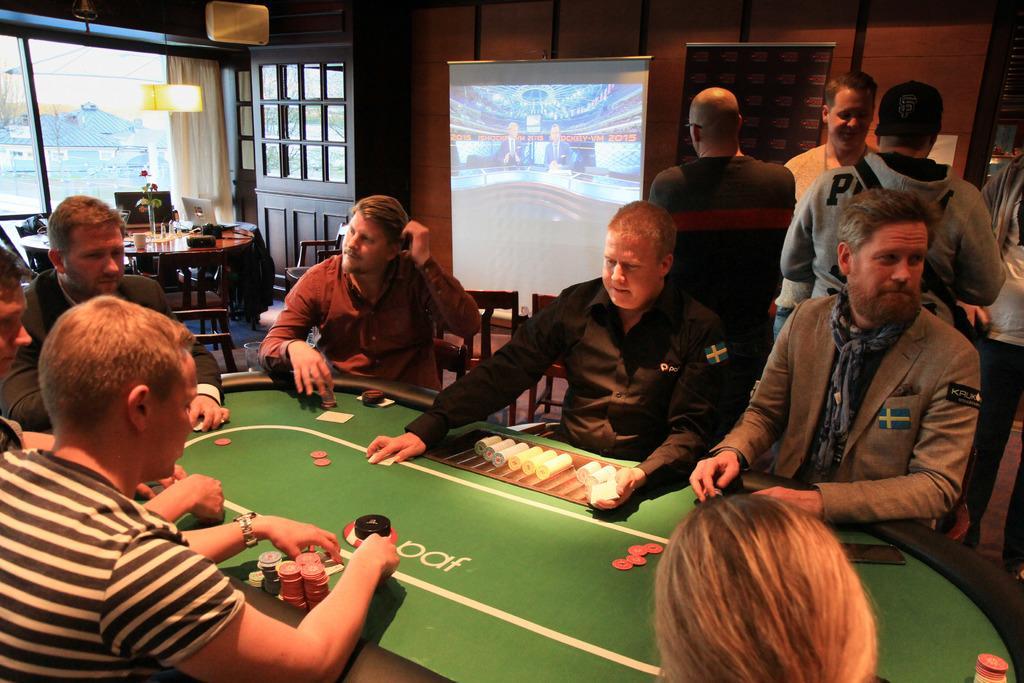Describe this image in one or two sentences. As we can see in the image there is a wall, window, screen, few people standing and sitting on chairs. 